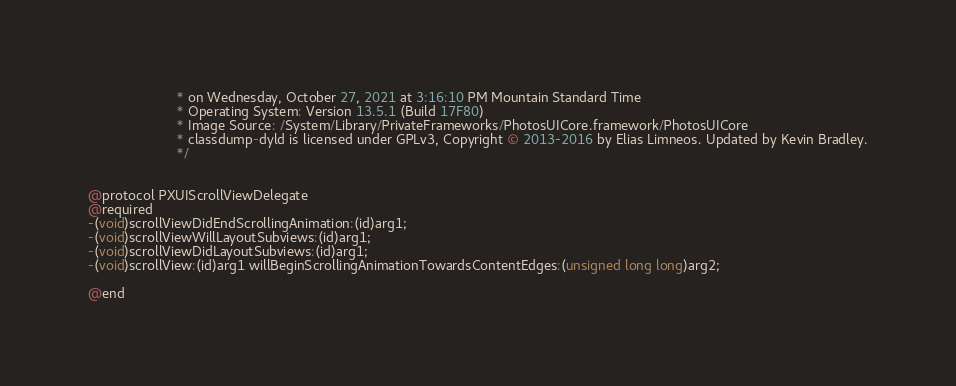Convert code to text. <code><loc_0><loc_0><loc_500><loc_500><_C_>                       * on Wednesday, October 27, 2021 at 3:16:10 PM Mountain Standard Time
                       * Operating System: Version 13.5.1 (Build 17F80)
                       * Image Source: /System/Library/PrivateFrameworks/PhotosUICore.framework/PhotosUICore
                       * classdump-dyld is licensed under GPLv3, Copyright © 2013-2016 by Elias Limneos. Updated by Kevin Bradley.
                       */


@protocol PXUIScrollViewDelegate
@required
-(void)scrollViewDidEndScrollingAnimation:(id)arg1;
-(void)scrollViewWillLayoutSubviews:(id)arg1;
-(void)scrollViewDidLayoutSubviews:(id)arg1;
-(void)scrollView:(id)arg1 willBeginScrollingAnimationTowardsContentEdges:(unsigned long long)arg2;

@end

</code> 